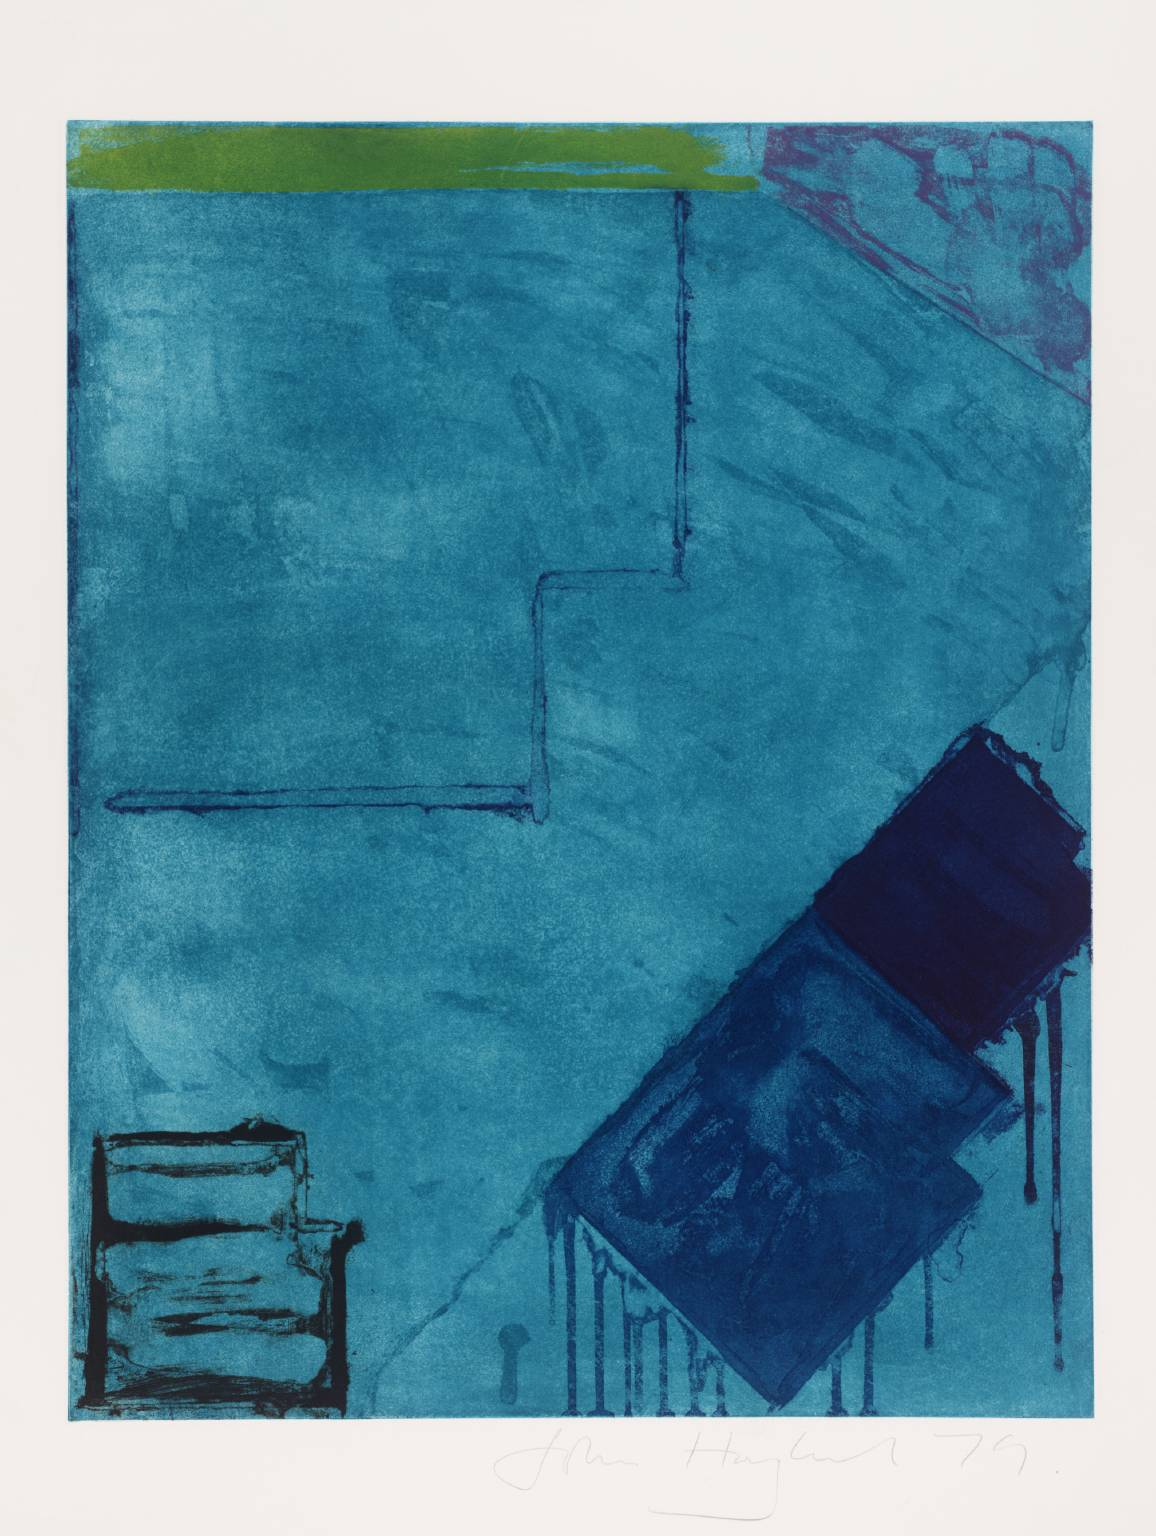Can you tell me more about the texture of the piece and what it adds to the artwork? The varied textures within the artwork, which range from smooth washes to more tactile, expressive marks, significantly enrich the visual experience. These textural elements give the piece a tangible quality, inviting viewers to imagine the sensations of touch. Additionally, they add dimension and physicality to what might otherwise be a flat abstract work, further highlighting the artist's layering and printing techniques. 